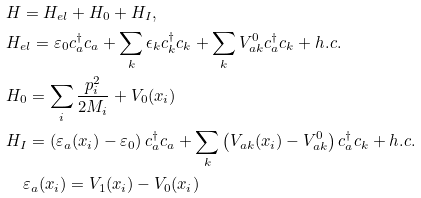Convert formula to latex. <formula><loc_0><loc_0><loc_500><loc_500>& H = H _ { e l } + H _ { 0 } + H _ { I } , \\ & H _ { e l } = \varepsilon _ { 0 } c _ { a } ^ { \dag } c _ { a } + \sum _ { k } \epsilon _ { k } c _ { k } ^ { \dag } c _ { k } + \sum _ { k } V _ { a k } ^ { 0 } c _ { a } ^ { \dag } c _ { k } + h . c . \\ & H _ { 0 } = \sum _ { i } \frac { p _ { i } ^ { 2 } } { 2 M _ { i } } + V _ { 0 } ( x _ { i } ) \\ & H _ { I } = \left ( \varepsilon _ { a } ( x _ { i } ) - \varepsilon _ { 0 } \right ) c _ { a } ^ { \dag } c _ { a } + \sum _ { k } \left ( V _ { a k } ( x _ { i } ) - V _ { a k } ^ { 0 } \right ) c _ { a } ^ { \dag } c _ { k } + h . c . \\ & \quad \varepsilon _ { a } ( x _ { i } ) = V _ { 1 } ( x _ { i } ) - V _ { 0 } ( x _ { i } )</formula> 